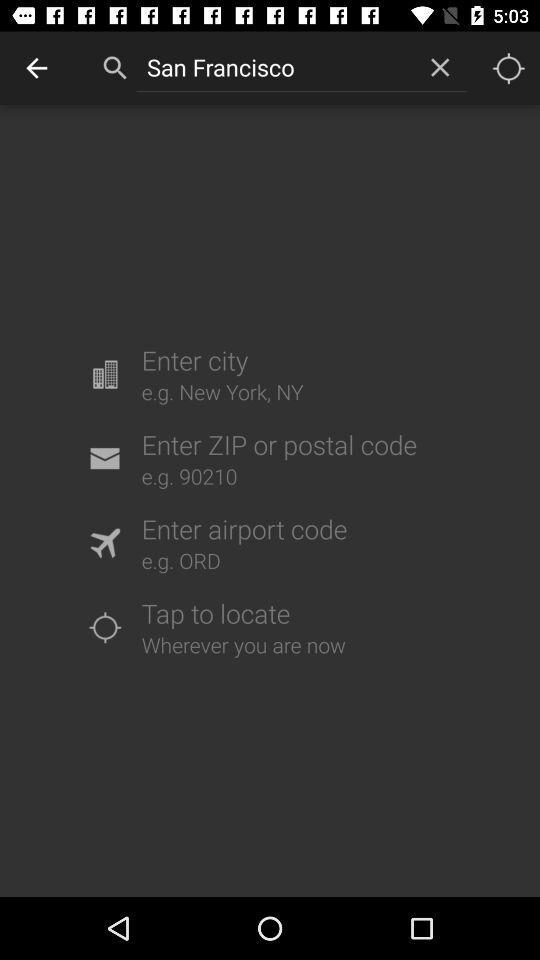What's the example for the ZIP or postal code? The example for the ZIP or postal code is 90210. 